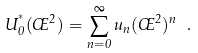<formula> <loc_0><loc_0><loc_500><loc_500>U _ { 0 } ^ { ^ { * } } ( \phi ^ { 2 } ) = \sum _ { n = 0 } ^ { \infty } u _ { n } ( \phi ^ { 2 } ) ^ { n } \ .</formula> 